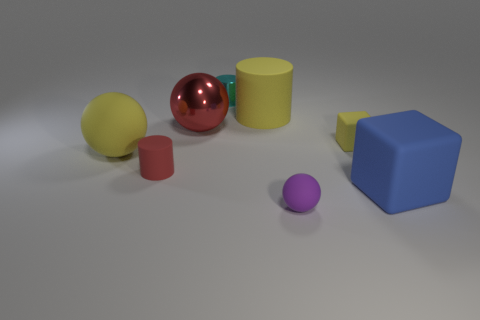The rubber sphere that is the same size as the cyan cylinder is what color?
Make the answer very short. Purple. There is a rubber object that is behind the large metallic object; what size is it?
Keep it short and to the point. Large. There is a blue matte object on the right side of the large cylinder; is there a tiny purple object that is right of it?
Your response must be concise. No. Are the red object behind the tiny red matte thing and the cyan cylinder made of the same material?
Your response must be concise. Yes. How many objects are both right of the red matte thing and behind the tiny purple object?
Your answer should be very brief. 5. How many tiny red cylinders have the same material as the big block?
Ensure brevity in your answer.  1. There is a cylinder that is made of the same material as the red sphere; what is its color?
Provide a short and direct response. Cyan. Is the number of metal cylinders less than the number of big purple shiny objects?
Offer a terse response. No. There is a big ball that is behind the rubber ball on the left side of the ball in front of the small red rubber object; what is its material?
Keep it short and to the point. Metal. What material is the red sphere?
Make the answer very short. Metal. 